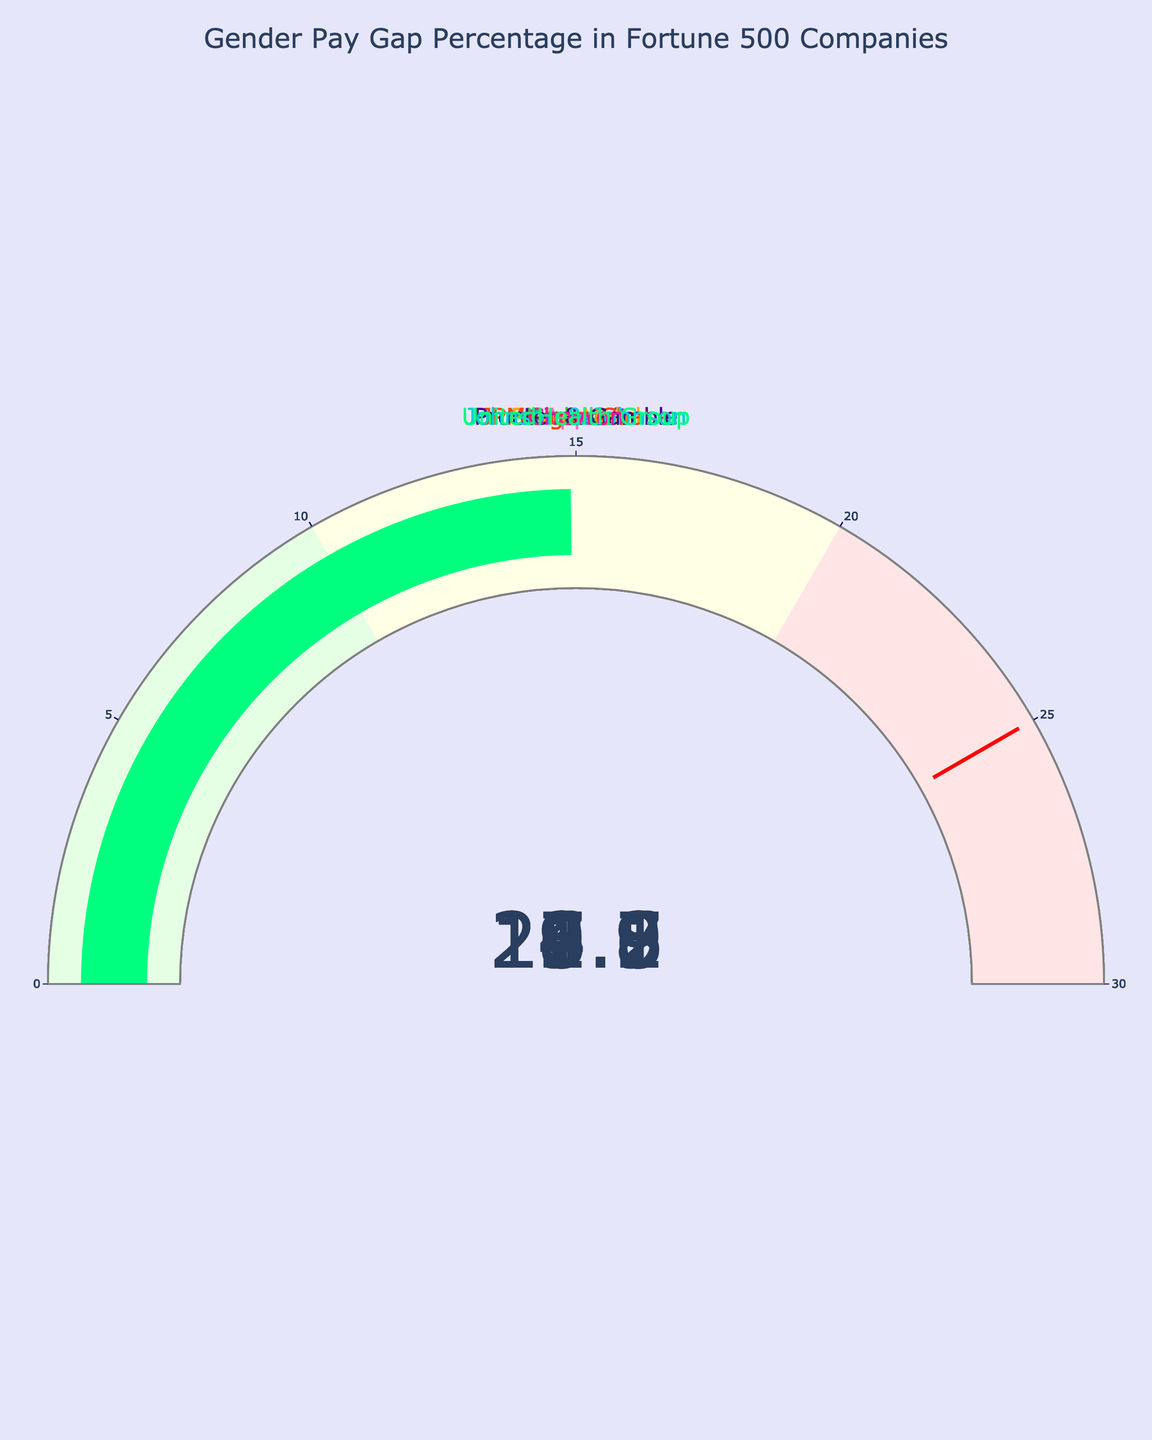What's the title of the figure? The title is found at the top of the figure, which is often used to summarize the content. In this case, it states the main topic it’s representing.
Answer: Gender Pay Gap Percentage in Fortune 500 Companies How many companies are represented in the figure? We count the number of different gauges or the number of companies listed near each gauge.
Answer: 10 Which company has the highest pay gap percentage? By looking at the gauges and identifying the one with the highest number, we can determine this.
Answer: Amazon Which company has the lowest pay gap percentage? By identifying the gauge with the lowest number, we can find out which company has the lowest percentage.
Answer: UnitedHealth Group What is the pay gap percentage at JPMorgan Chase? Locate the gauge representing JPMorgan Chase and read the number it displays.
Answer: 16.3 Compare the pay gap percentages between Apple and ExxonMobil. Which is higher? Identify the gauges for both Apple and ExxonMobil, then compare their values directly.
Answer: ExxonMobil What is the average pay gap percentage among the companies displayed? Sum all the pay gap percentages and divide by the number of companies (10). So, (17.5 + 19.8 + 23.2 + 15.6 + 21.9 + 16.3 + 18.7 + 20.1 + 22.8 + 14.9) / 10 = (190.8 / 10)
Answer: 19.08 How many companies have a pay gap percentage greater than 20%? Count the number of gauges that display a value greater than 20.
Answer: 4 Is the pay gap percentage of Procter & Gamble closer to that of Apple or Microsoft? Compare the pay gap percentage of Procter & Gamble (18.7) with that of Apple (17.5) and Microsoft (19.8).
Answer: Apple What's the difference between the highest and lowest pay gap percentages in the figure? Subtract the lowest value (UnitedHealth Group, 14.9) from the highest (Amazon, 23.2). So, 23.2 - 14.9 = 8.3
Answer: 8.3 